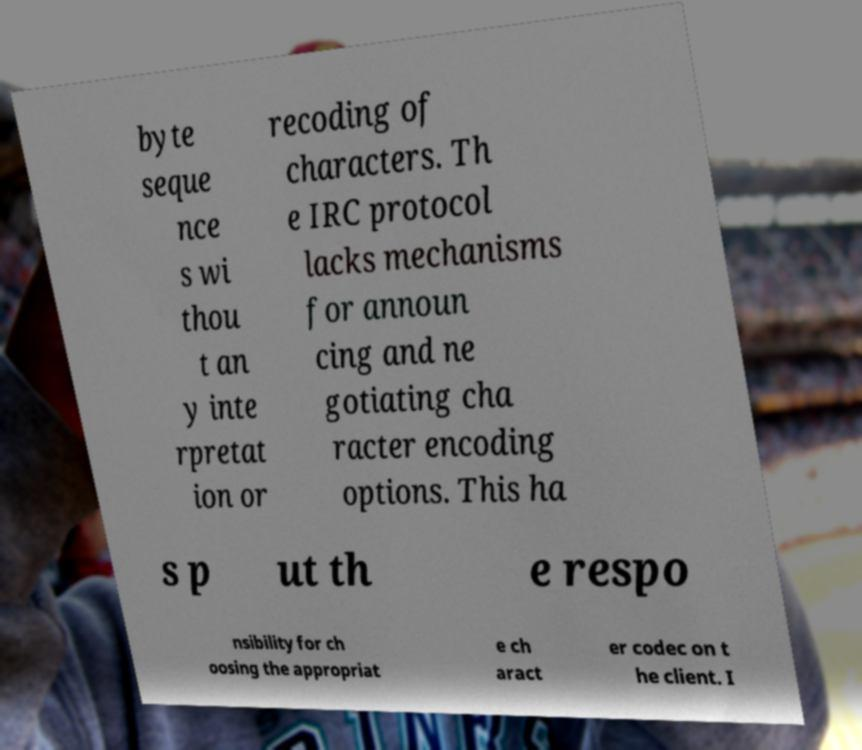For documentation purposes, I need the text within this image transcribed. Could you provide that? byte seque nce s wi thou t an y inte rpretat ion or recoding of characters. Th e IRC protocol lacks mechanisms for announ cing and ne gotiating cha racter encoding options. This ha s p ut th e respo nsibility for ch oosing the appropriat e ch aract er codec on t he client. I 